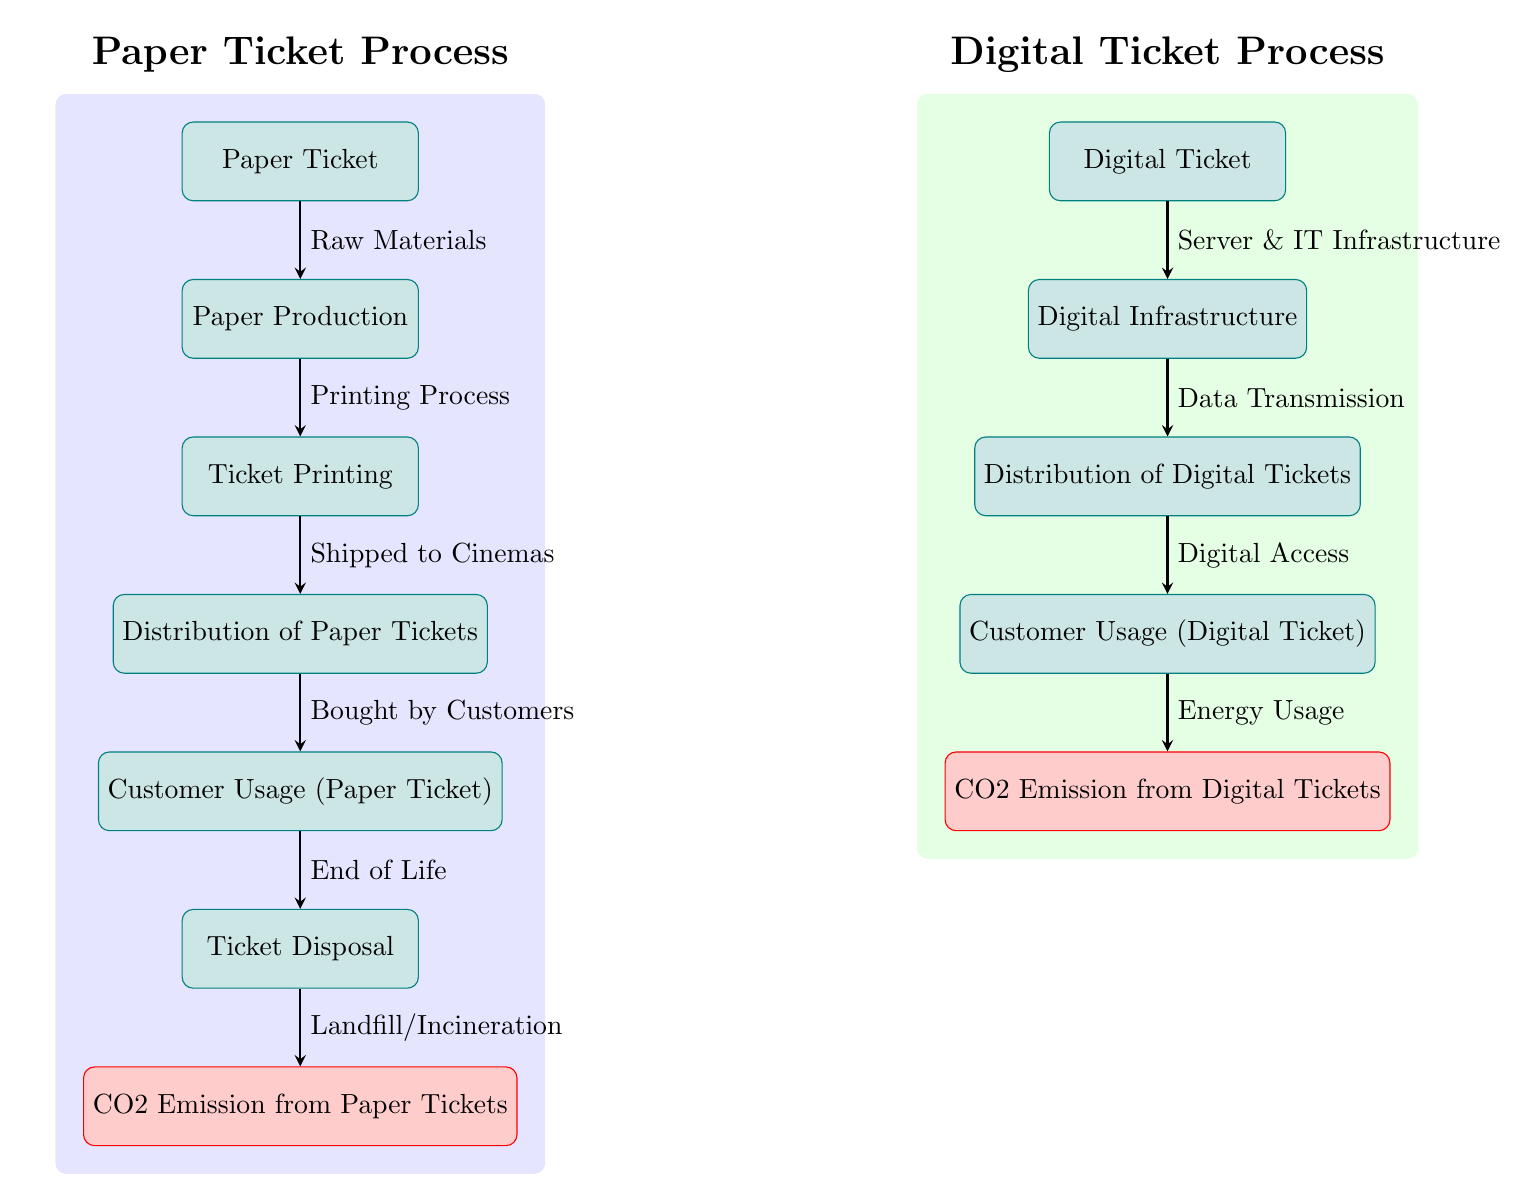What is the final node in the Paper Ticket process? The final node in the Paper Ticket process is "CO2 Emission from Paper Tickets," which is located below the "Ticket Disposal" node, as indicated in the diagram.
Answer: CO2 Emission from Paper Tickets How many processes are involved in the Digital Ticket path? In the Digital Ticket path, there are four processes: "Digital Ticket," "Digital Infrastructure," "Distribution of Digital Tickets," and "Customer Usage (Digital Ticket)." Counting these gives a total of four processes.
Answer: 4 What type of emissions is associated with Customer Usage for Digital Tickets? The type of emissions associated with "Customer Usage (Digital Ticket)" is "Energy Usage," which directly contributes to the CO2 emissions for digital tickets. This relationship is clearly indicated by an arrow pointing from the usage node to the CO2 emission node.
Answer: Energy Usage Which ticket process has a step for disposal? The ticket process that has a step for disposal is the Paper Ticket process, which includes the "Ticket Disposal" step before the final CO2 emission node. The Digital Ticket process does not include a disposal step.
Answer: Paper Ticket What is the connection between Ticket Printing and CO2 Emission from Paper Tickets? The connection is that the "Ticket Printing" node leads to the "Distribution of Paper Tickets," which ultimately leads to "Ticket Disposal" and finally to the "CO2 Emission from Paper Tickets." This sequence shows the flow from printing to the emission of CO2.
Answer: Flow of processes How do emissions from digital tickets compare to those from paper tickets? The comparison is made by analyzing the CO2 emissions from "CO2 Emission from Digital Tickets" against "CO2 Emission from Paper Tickets." While both end in emissions, the diagram leads to the conclusion that energy usage is crucial in digital emissions as opposed to disposal methods for paper tickets.
Answer: Emission Analysis 